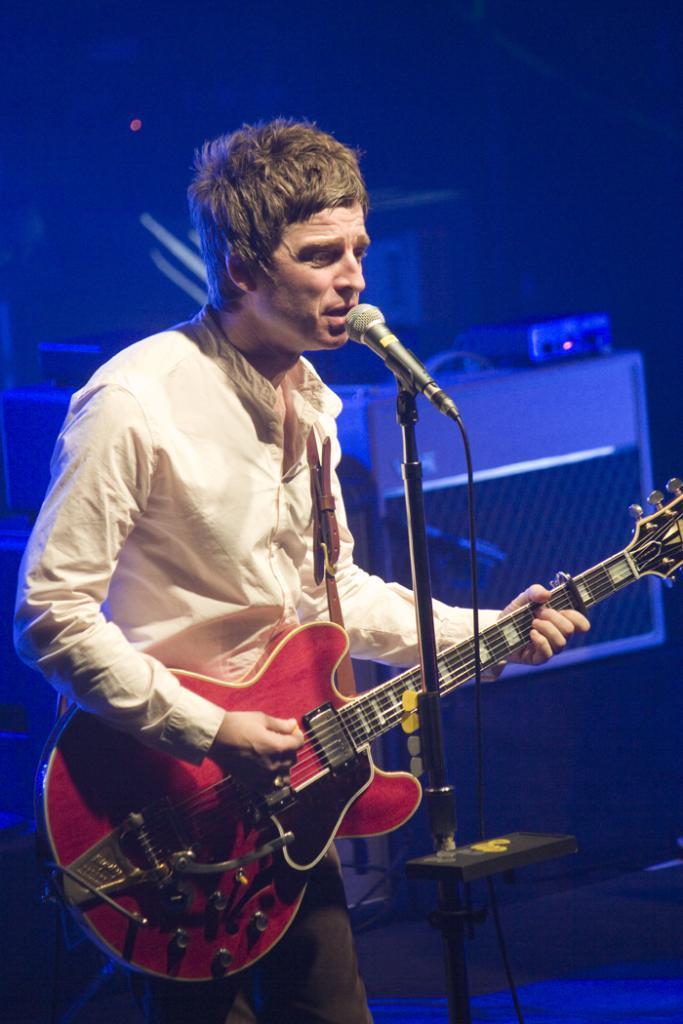Can you describe this image briefly? In this image I can see a person standing and singing in front of the microphone, and the person is holding a guitar. The person is wearing cream color shirt and brown color pant and I can see blue color background. 